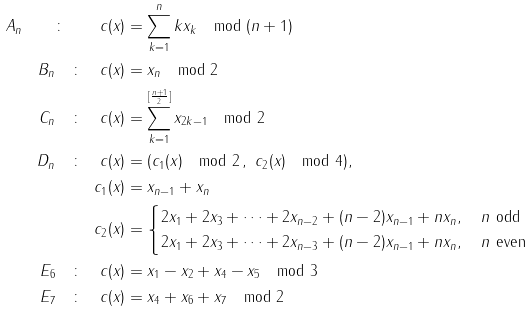<formula> <loc_0><loc_0><loc_500><loc_500>A _ { n } \quad \colon \quad c ( x ) & = \sum _ { k = 1 } ^ { n } k x _ { k } \mod ( n + 1 ) \\ B _ { n } \quad \colon \quad c ( x ) & = x _ { n } \mod 2 \\ C _ { n } \quad \colon \quad c ( x ) & = \sum _ { k = 1 } ^ { [ \frac { n + 1 } 2 ] } x _ { 2 k - 1 } \mod 2 \\ D _ { n } \quad \colon \quad c ( x ) & = ( c _ { 1 } ( x ) \mod 2 \, , \ c _ { 2 } ( x ) \mod 4 ) , \\ c _ { 1 } ( x ) & = x _ { n - 1 } + x _ { n } \\ c _ { 2 } ( x ) & = \begin{cases} 2 x _ { 1 } + 2 x _ { 3 } + \dots + 2 x _ { n - 2 } + ( n - 2 ) x _ { n - 1 } + n x _ { n } , \quad n \ \text {odd} \\ 2 x _ { 1 } + 2 x _ { 3 } + \dots + 2 x _ { n - 3 } + ( n - 2 ) x _ { n - 1 } + n x _ { n } , \quad n \ \text {even} \end{cases} \\ E _ { 6 } \quad \colon \quad c ( x ) & = x _ { 1 } - x _ { 2 } + x _ { 4 } - x _ { 5 } \mod 3 \\ E _ { 7 } \quad \colon \quad c ( x ) & = x _ { 4 } + x _ { 6 } + x _ { 7 } \mod 2</formula> 